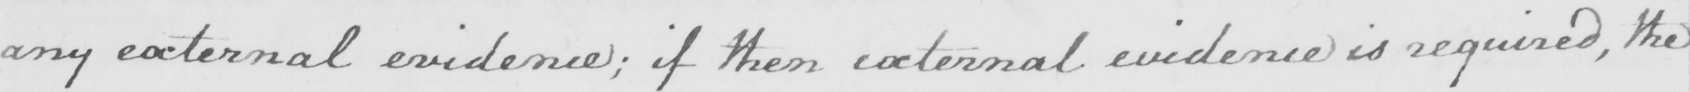What is written in this line of handwriting? any external evidence ; if then external evidence is required , the 